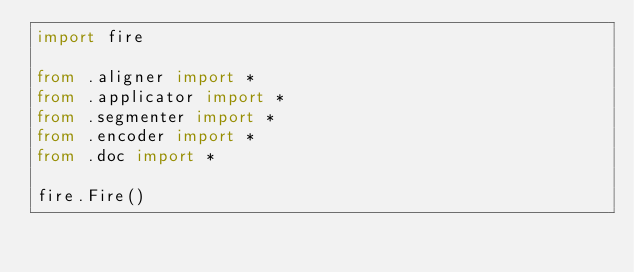<code> <loc_0><loc_0><loc_500><loc_500><_Python_>import fire

from .aligner import *
from .applicator import *
from .segmenter import *
from .encoder import *
from .doc import *

fire.Fire()
</code> 